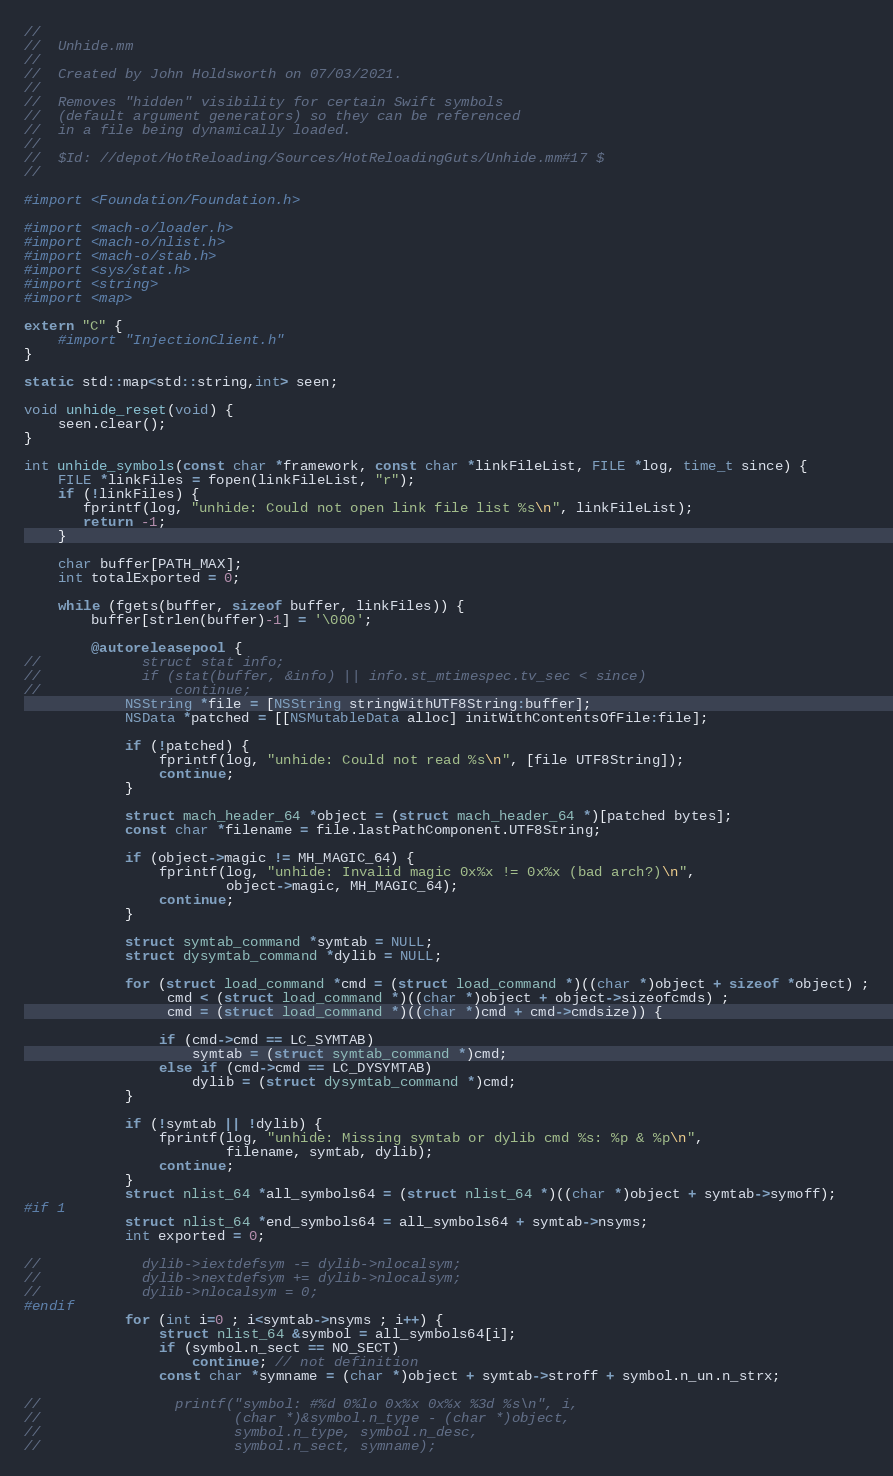Convert code to text. <code><loc_0><loc_0><loc_500><loc_500><_ObjectiveC_>//
//  Unhide.mm
//
//  Created by John Holdsworth on 07/03/2021.
//
//  Removes "hidden" visibility for certain Swift symbols
//  (default argument generators) so they can be referenced
//  in a file being dynamically loaded.
//
//  $Id: //depot/HotReloading/Sources/HotReloadingGuts/Unhide.mm#17 $
//

#import <Foundation/Foundation.h>

#import <mach-o/loader.h>
#import <mach-o/nlist.h>
#import <mach-o/stab.h>
#import <sys/stat.h>
#import <string>
#import <map>

extern "C" {
    #import "InjectionClient.h"
}

static std::map<std::string,int> seen;

void unhide_reset(void) {
    seen.clear();
}

int unhide_symbols(const char *framework, const char *linkFileList, FILE *log, time_t since) {
    FILE *linkFiles = fopen(linkFileList, "r");
    if (!linkFiles) {
       fprintf(log, "unhide: Could not open link file list %s\n", linkFileList);
       return -1;
    }

    char buffer[PATH_MAX];
    int totalExported = 0;

    while (fgets(buffer, sizeof buffer, linkFiles)) {
        buffer[strlen(buffer)-1] = '\000';

        @autoreleasepool {
//            struct stat info;
//            if (stat(buffer, &info) || info.st_mtimespec.tv_sec < since)
//                continue;
            NSString *file = [NSString stringWithUTF8String:buffer];
            NSData *patched = [[NSMutableData alloc] initWithContentsOfFile:file];

            if (!patched) {
                fprintf(log, "unhide: Could not read %s\n", [file UTF8String]);
                continue;
            }

            struct mach_header_64 *object = (struct mach_header_64 *)[patched bytes];
            const char *filename = file.lastPathComponent.UTF8String;

            if (object->magic != MH_MAGIC_64) {
                fprintf(log, "unhide: Invalid magic 0x%x != 0x%x (bad arch?)\n",
                        object->magic, MH_MAGIC_64);
                continue;
            }

            struct symtab_command *symtab = NULL;
            struct dysymtab_command *dylib = NULL;

            for (struct load_command *cmd = (struct load_command *)((char *)object + sizeof *object) ;
                 cmd < (struct load_command *)((char *)object + object->sizeofcmds) ;
                 cmd = (struct load_command *)((char *)cmd + cmd->cmdsize)) {

                if (cmd->cmd == LC_SYMTAB)
                    symtab = (struct symtab_command *)cmd;
                else if (cmd->cmd == LC_DYSYMTAB)
                    dylib = (struct dysymtab_command *)cmd;
            }

            if (!symtab || !dylib) {
                fprintf(log, "unhide: Missing symtab or dylib cmd %s: %p & %p\n",
                        filename, symtab, dylib);
                continue;
            }
            struct nlist_64 *all_symbols64 = (struct nlist_64 *)((char *)object + symtab->symoff);
#if 1
            struct nlist_64 *end_symbols64 = all_symbols64 + symtab->nsyms;
            int exported = 0;

//            dylib->iextdefsym -= dylib->nlocalsym;
//            dylib->nextdefsym += dylib->nlocalsym;
//            dylib->nlocalsym = 0;
#endif
            for (int i=0 ; i<symtab->nsyms ; i++) {
                struct nlist_64 &symbol = all_symbols64[i];
                if (symbol.n_sect == NO_SECT)
                    continue; // not definition
                const char *symname = (char *)object + symtab->stroff + symbol.n_un.n_strx;

//                printf("symbol: #%d 0%lo 0x%x 0x%x %3d %s\n", i,
//                       (char *)&symbol.n_type - (char *)object,
//                       symbol.n_type, symbol.n_desc,
//                       symbol.n_sect, symname);</code> 